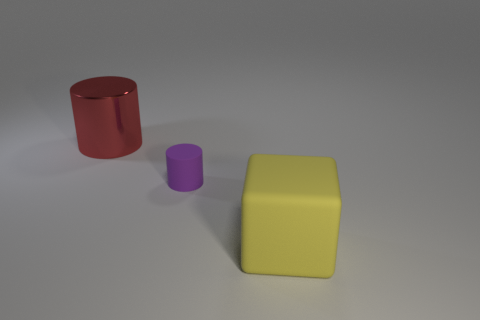Add 3 large metal things. How many objects exist? 6 Subtract all cylinders. How many objects are left? 1 Add 3 purple matte things. How many purple matte things are left? 4 Add 3 yellow rubber things. How many yellow rubber things exist? 4 Subtract 1 yellow cubes. How many objects are left? 2 Subtract all small rubber cylinders. Subtract all small purple rubber cylinders. How many objects are left? 1 